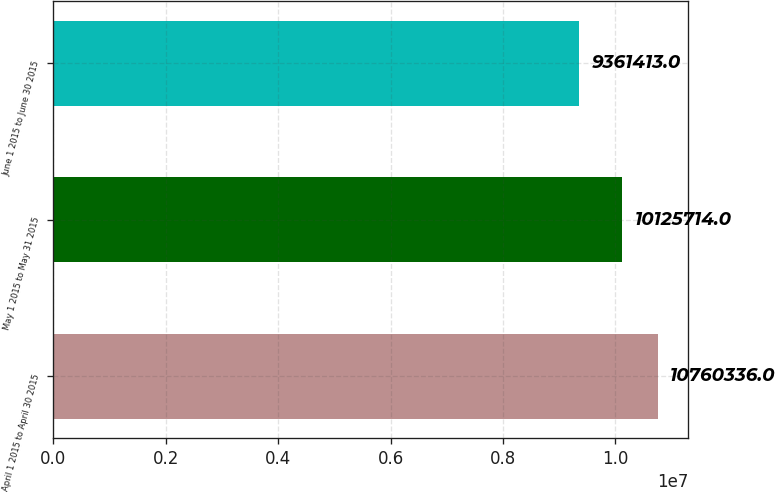<chart> <loc_0><loc_0><loc_500><loc_500><bar_chart><fcel>April 1 2015 to April 30 2015<fcel>May 1 2015 to May 31 2015<fcel>June 1 2015 to June 30 2015<nl><fcel>1.07603e+07<fcel>1.01257e+07<fcel>9.36141e+06<nl></chart> 